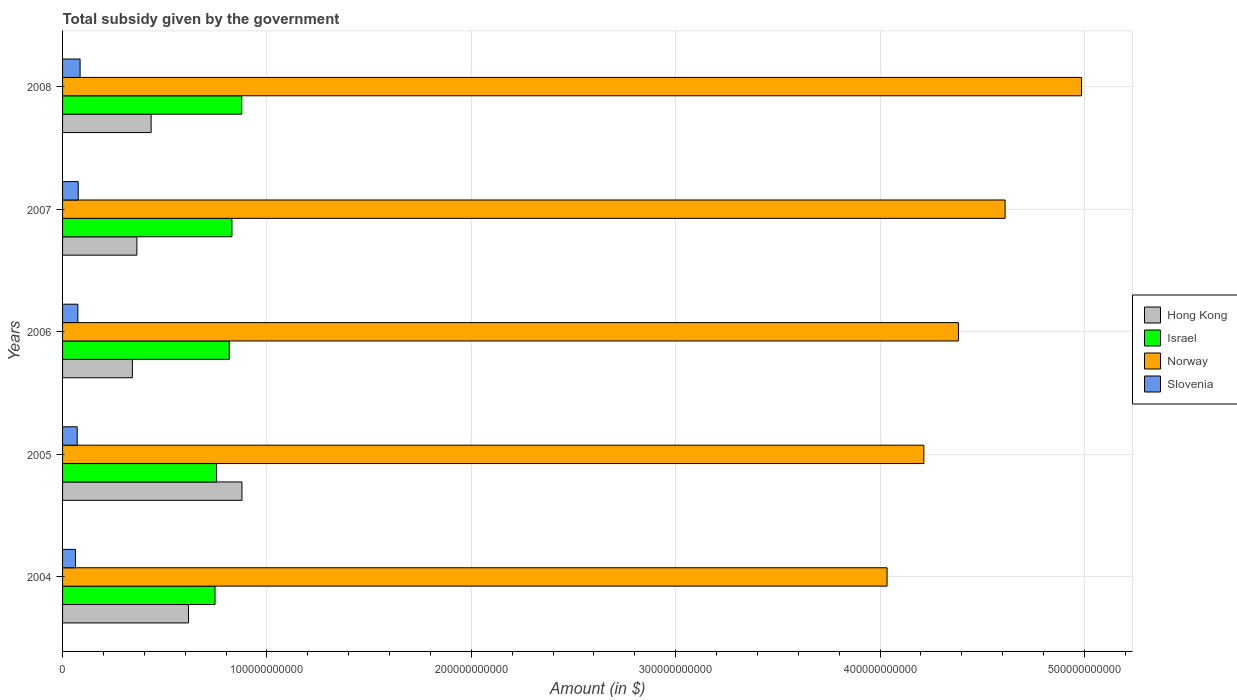How many groups of bars are there?
Your response must be concise. 5. Are the number of bars per tick equal to the number of legend labels?
Offer a very short reply. Yes. How many bars are there on the 3rd tick from the top?
Provide a succinct answer. 4. What is the total revenue collected by the government in Slovenia in 2005?
Your answer should be compact. 7.16e+09. Across all years, what is the maximum total revenue collected by the government in Hong Kong?
Provide a short and direct response. 8.78e+1. Across all years, what is the minimum total revenue collected by the government in Israel?
Make the answer very short. 7.46e+1. In which year was the total revenue collected by the government in Hong Kong minimum?
Keep it short and to the point. 2006. What is the total total revenue collected by the government in Norway in the graph?
Offer a very short reply. 2.22e+12. What is the difference between the total revenue collected by the government in Hong Kong in 2005 and that in 2008?
Your answer should be compact. 4.44e+1. What is the difference between the total revenue collected by the government in Hong Kong in 2004 and the total revenue collected by the government in Norway in 2005?
Give a very brief answer. -3.60e+11. What is the average total revenue collected by the government in Norway per year?
Offer a very short reply. 4.45e+11. In the year 2006, what is the difference between the total revenue collected by the government in Norway and total revenue collected by the government in Hong Kong?
Keep it short and to the point. 4.04e+11. In how many years, is the total revenue collected by the government in Norway greater than 220000000000 $?
Ensure brevity in your answer.  5. What is the ratio of the total revenue collected by the government in Israel in 2004 to that in 2006?
Ensure brevity in your answer.  0.91. Is the total revenue collected by the government in Slovenia in 2006 less than that in 2008?
Provide a succinct answer. Yes. What is the difference between the highest and the second highest total revenue collected by the government in Israel?
Provide a short and direct response. 4.80e+09. What is the difference between the highest and the lowest total revenue collected by the government in Israel?
Make the answer very short. 1.31e+1. Is the sum of the total revenue collected by the government in Norway in 2004 and 2008 greater than the maximum total revenue collected by the government in Hong Kong across all years?
Your answer should be compact. Yes. Is it the case that in every year, the sum of the total revenue collected by the government in Slovenia and total revenue collected by the government in Hong Kong is greater than the sum of total revenue collected by the government in Israel and total revenue collected by the government in Norway?
Give a very brief answer. No. What does the 4th bar from the bottom in 2007 represents?
Your answer should be compact. Slovenia. Are all the bars in the graph horizontal?
Your answer should be very brief. Yes. How many years are there in the graph?
Offer a terse response. 5. What is the difference between two consecutive major ticks on the X-axis?
Give a very brief answer. 1.00e+11. How are the legend labels stacked?
Provide a short and direct response. Vertical. What is the title of the graph?
Ensure brevity in your answer.  Total subsidy given by the government. Does "Bhutan" appear as one of the legend labels in the graph?
Provide a short and direct response. No. What is the label or title of the X-axis?
Give a very brief answer. Amount (in $). What is the Amount (in $) in Hong Kong in 2004?
Offer a terse response. 6.16e+1. What is the Amount (in $) of Israel in 2004?
Provide a succinct answer. 7.46e+1. What is the Amount (in $) of Norway in 2004?
Provide a short and direct response. 4.03e+11. What is the Amount (in $) of Slovenia in 2004?
Give a very brief answer. 6.31e+09. What is the Amount (in $) in Hong Kong in 2005?
Make the answer very short. 8.78e+1. What is the Amount (in $) in Israel in 2005?
Offer a terse response. 7.53e+1. What is the Amount (in $) in Norway in 2005?
Keep it short and to the point. 4.21e+11. What is the Amount (in $) in Slovenia in 2005?
Offer a very short reply. 7.16e+09. What is the Amount (in $) of Hong Kong in 2006?
Provide a succinct answer. 3.42e+1. What is the Amount (in $) in Israel in 2006?
Offer a very short reply. 8.16e+1. What is the Amount (in $) in Norway in 2006?
Keep it short and to the point. 4.38e+11. What is the Amount (in $) of Slovenia in 2006?
Make the answer very short. 7.48e+09. What is the Amount (in $) in Hong Kong in 2007?
Provide a short and direct response. 3.64e+1. What is the Amount (in $) in Israel in 2007?
Give a very brief answer. 8.29e+1. What is the Amount (in $) in Norway in 2007?
Your answer should be compact. 4.61e+11. What is the Amount (in $) of Slovenia in 2007?
Your answer should be very brief. 7.66e+09. What is the Amount (in $) in Hong Kong in 2008?
Keep it short and to the point. 4.33e+1. What is the Amount (in $) in Israel in 2008?
Offer a very short reply. 8.77e+1. What is the Amount (in $) of Norway in 2008?
Make the answer very short. 4.99e+11. What is the Amount (in $) in Slovenia in 2008?
Make the answer very short. 8.58e+09. Across all years, what is the maximum Amount (in $) of Hong Kong?
Provide a short and direct response. 8.78e+1. Across all years, what is the maximum Amount (in $) of Israel?
Keep it short and to the point. 8.77e+1. Across all years, what is the maximum Amount (in $) of Norway?
Your answer should be very brief. 4.99e+11. Across all years, what is the maximum Amount (in $) in Slovenia?
Your answer should be compact. 8.58e+09. Across all years, what is the minimum Amount (in $) of Hong Kong?
Provide a short and direct response. 3.42e+1. Across all years, what is the minimum Amount (in $) in Israel?
Offer a terse response. 7.46e+1. Across all years, what is the minimum Amount (in $) in Norway?
Provide a succinct answer. 4.03e+11. Across all years, what is the minimum Amount (in $) of Slovenia?
Provide a succinct answer. 6.31e+09. What is the total Amount (in $) in Hong Kong in the graph?
Your answer should be compact. 2.63e+11. What is the total Amount (in $) in Israel in the graph?
Offer a very short reply. 4.02e+11. What is the total Amount (in $) of Norway in the graph?
Offer a very short reply. 2.22e+12. What is the total Amount (in $) of Slovenia in the graph?
Offer a terse response. 3.72e+1. What is the difference between the Amount (in $) of Hong Kong in 2004 and that in 2005?
Your answer should be compact. -2.62e+1. What is the difference between the Amount (in $) in Israel in 2004 and that in 2005?
Make the answer very short. -7.47e+08. What is the difference between the Amount (in $) in Norway in 2004 and that in 2005?
Your response must be concise. -1.80e+1. What is the difference between the Amount (in $) in Slovenia in 2004 and that in 2005?
Provide a succinct answer. -8.53e+08. What is the difference between the Amount (in $) in Hong Kong in 2004 and that in 2006?
Your response must be concise. 2.75e+1. What is the difference between the Amount (in $) in Israel in 2004 and that in 2006?
Your answer should be very brief. -6.97e+09. What is the difference between the Amount (in $) in Norway in 2004 and that in 2006?
Your answer should be compact. -3.49e+1. What is the difference between the Amount (in $) of Slovenia in 2004 and that in 2006?
Make the answer very short. -1.18e+09. What is the difference between the Amount (in $) in Hong Kong in 2004 and that in 2007?
Your answer should be very brief. 2.53e+1. What is the difference between the Amount (in $) in Israel in 2004 and that in 2007?
Give a very brief answer. -8.28e+09. What is the difference between the Amount (in $) of Norway in 2004 and that in 2007?
Offer a very short reply. -5.78e+1. What is the difference between the Amount (in $) in Slovenia in 2004 and that in 2007?
Give a very brief answer. -1.35e+09. What is the difference between the Amount (in $) of Hong Kong in 2004 and that in 2008?
Provide a succinct answer. 1.83e+1. What is the difference between the Amount (in $) in Israel in 2004 and that in 2008?
Offer a very short reply. -1.31e+1. What is the difference between the Amount (in $) in Norway in 2004 and that in 2008?
Provide a succinct answer. -9.51e+1. What is the difference between the Amount (in $) of Slovenia in 2004 and that in 2008?
Provide a short and direct response. -2.27e+09. What is the difference between the Amount (in $) in Hong Kong in 2005 and that in 2006?
Provide a succinct answer. 5.36e+1. What is the difference between the Amount (in $) of Israel in 2005 and that in 2006?
Your answer should be compact. -6.22e+09. What is the difference between the Amount (in $) of Norway in 2005 and that in 2006?
Your response must be concise. -1.69e+1. What is the difference between the Amount (in $) of Slovenia in 2005 and that in 2006?
Your answer should be very brief. -3.23e+08. What is the difference between the Amount (in $) in Hong Kong in 2005 and that in 2007?
Offer a very short reply. 5.14e+1. What is the difference between the Amount (in $) of Israel in 2005 and that in 2007?
Offer a very short reply. -7.54e+09. What is the difference between the Amount (in $) of Norway in 2005 and that in 2007?
Offer a very short reply. -3.98e+1. What is the difference between the Amount (in $) of Slovenia in 2005 and that in 2007?
Provide a short and direct response. -4.96e+08. What is the difference between the Amount (in $) of Hong Kong in 2005 and that in 2008?
Provide a succinct answer. 4.44e+1. What is the difference between the Amount (in $) of Israel in 2005 and that in 2008?
Your response must be concise. -1.23e+1. What is the difference between the Amount (in $) in Norway in 2005 and that in 2008?
Provide a short and direct response. -7.71e+1. What is the difference between the Amount (in $) of Slovenia in 2005 and that in 2008?
Make the answer very short. -1.42e+09. What is the difference between the Amount (in $) in Hong Kong in 2006 and that in 2007?
Offer a very short reply. -2.20e+09. What is the difference between the Amount (in $) in Israel in 2006 and that in 2007?
Your response must be concise. -1.32e+09. What is the difference between the Amount (in $) in Norway in 2006 and that in 2007?
Keep it short and to the point. -2.28e+1. What is the difference between the Amount (in $) of Slovenia in 2006 and that in 2007?
Your answer should be very brief. -1.73e+08. What is the difference between the Amount (in $) in Hong Kong in 2006 and that in 2008?
Your answer should be very brief. -9.17e+09. What is the difference between the Amount (in $) in Israel in 2006 and that in 2008?
Your answer should be very brief. -6.12e+09. What is the difference between the Amount (in $) of Norway in 2006 and that in 2008?
Keep it short and to the point. -6.02e+1. What is the difference between the Amount (in $) of Slovenia in 2006 and that in 2008?
Your response must be concise. -1.09e+09. What is the difference between the Amount (in $) in Hong Kong in 2007 and that in 2008?
Provide a short and direct response. -6.98e+09. What is the difference between the Amount (in $) of Israel in 2007 and that in 2008?
Give a very brief answer. -4.80e+09. What is the difference between the Amount (in $) of Norway in 2007 and that in 2008?
Offer a terse response. -3.74e+1. What is the difference between the Amount (in $) in Slovenia in 2007 and that in 2008?
Your response must be concise. -9.21e+08. What is the difference between the Amount (in $) of Hong Kong in 2004 and the Amount (in $) of Israel in 2005?
Offer a very short reply. -1.37e+1. What is the difference between the Amount (in $) of Hong Kong in 2004 and the Amount (in $) of Norway in 2005?
Keep it short and to the point. -3.60e+11. What is the difference between the Amount (in $) in Hong Kong in 2004 and the Amount (in $) in Slovenia in 2005?
Your answer should be very brief. 5.45e+1. What is the difference between the Amount (in $) of Israel in 2004 and the Amount (in $) of Norway in 2005?
Provide a succinct answer. -3.47e+11. What is the difference between the Amount (in $) of Israel in 2004 and the Amount (in $) of Slovenia in 2005?
Provide a short and direct response. 6.74e+1. What is the difference between the Amount (in $) of Norway in 2004 and the Amount (in $) of Slovenia in 2005?
Keep it short and to the point. 3.96e+11. What is the difference between the Amount (in $) in Hong Kong in 2004 and the Amount (in $) in Israel in 2006?
Offer a very short reply. -1.99e+1. What is the difference between the Amount (in $) of Hong Kong in 2004 and the Amount (in $) of Norway in 2006?
Provide a short and direct response. -3.77e+11. What is the difference between the Amount (in $) in Hong Kong in 2004 and the Amount (in $) in Slovenia in 2006?
Your answer should be compact. 5.41e+1. What is the difference between the Amount (in $) of Israel in 2004 and the Amount (in $) of Norway in 2006?
Make the answer very short. -3.64e+11. What is the difference between the Amount (in $) of Israel in 2004 and the Amount (in $) of Slovenia in 2006?
Keep it short and to the point. 6.71e+1. What is the difference between the Amount (in $) of Norway in 2004 and the Amount (in $) of Slovenia in 2006?
Your answer should be compact. 3.96e+11. What is the difference between the Amount (in $) of Hong Kong in 2004 and the Amount (in $) of Israel in 2007?
Ensure brevity in your answer.  -2.13e+1. What is the difference between the Amount (in $) in Hong Kong in 2004 and the Amount (in $) in Norway in 2007?
Give a very brief answer. -4.00e+11. What is the difference between the Amount (in $) in Hong Kong in 2004 and the Amount (in $) in Slovenia in 2007?
Make the answer very short. 5.40e+1. What is the difference between the Amount (in $) of Israel in 2004 and the Amount (in $) of Norway in 2007?
Your answer should be very brief. -3.87e+11. What is the difference between the Amount (in $) of Israel in 2004 and the Amount (in $) of Slovenia in 2007?
Offer a very short reply. 6.69e+1. What is the difference between the Amount (in $) of Norway in 2004 and the Amount (in $) of Slovenia in 2007?
Your answer should be very brief. 3.96e+11. What is the difference between the Amount (in $) in Hong Kong in 2004 and the Amount (in $) in Israel in 2008?
Provide a succinct answer. -2.61e+1. What is the difference between the Amount (in $) in Hong Kong in 2004 and the Amount (in $) in Norway in 2008?
Make the answer very short. -4.37e+11. What is the difference between the Amount (in $) of Hong Kong in 2004 and the Amount (in $) of Slovenia in 2008?
Offer a very short reply. 5.30e+1. What is the difference between the Amount (in $) of Israel in 2004 and the Amount (in $) of Norway in 2008?
Your answer should be compact. -4.24e+11. What is the difference between the Amount (in $) of Israel in 2004 and the Amount (in $) of Slovenia in 2008?
Your response must be concise. 6.60e+1. What is the difference between the Amount (in $) in Norway in 2004 and the Amount (in $) in Slovenia in 2008?
Your answer should be very brief. 3.95e+11. What is the difference between the Amount (in $) in Hong Kong in 2005 and the Amount (in $) in Israel in 2006?
Keep it short and to the point. 6.22e+09. What is the difference between the Amount (in $) of Hong Kong in 2005 and the Amount (in $) of Norway in 2006?
Offer a terse response. -3.51e+11. What is the difference between the Amount (in $) in Hong Kong in 2005 and the Amount (in $) in Slovenia in 2006?
Offer a very short reply. 8.03e+1. What is the difference between the Amount (in $) in Israel in 2005 and the Amount (in $) in Norway in 2006?
Keep it short and to the point. -3.63e+11. What is the difference between the Amount (in $) of Israel in 2005 and the Amount (in $) of Slovenia in 2006?
Offer a terse response. 6.79e+1. What is the difference between the Amount (in $) in Norway in 2005 and the Amount (in $) in Slovenia in 2006?
Ensure brevity in your answer.  4.14e+11. What is the difference between the Amount (in $) in Hong Kong in 2005 and the Amount (in $) in Israel in 2007?
Your answer should be very brief. 4.90e+09. What is the difference between the Amount (in $) in Hong Kong in 2005 and the Amount (in $) in Norway in 2007?
Make the answer very short. -3.73e+11. What is the difference between the Amount (in $) of Hong Kong in 2005 and the Amount (in $) of Slovenia in 2007?
Your answer should be compact. 8.01e+1. What is the difference between the Amount (in $) in Israel in 2005 and the Amount (in $) in Norway in 2007?
Keep it short and to the point. -3.86e+11. What is the difference between the Amount (in $) in Israel in 2005 and the Amount (in $) in Slovenia in 2007?
Your answer should be very brief. 6.77e+1. What is the difference between the Amount (in $) of Norway in 2005 and the Amount (in $) of Slovenia in 2007?
Your answer should be very brief. 4.14e+11. What is the difference between the Amount (in $) in Hong Kong in 2005 and the Amount (in $) in Israel in 2008?
Keep it short and to the point. 9.97e+07. What is the difference between the Amount (in $) in Hong Kong in 2005 and the Amount (in $) in Norway in 2008?
Provide a succinct answer. -4.11e+11. What is the difference between the Amount (in $) of Hong Kong in 2005 and the Amount (in $) of Slovenia in 2008?
Your answer should be compact. 7.92e+1. What is the difference between the Amount (in $) of Israel in 2005 and the Amount (in $) of Norway in 2008?
Your answer should be compact. -4.23e+11. What is the difference between the Amount (in $) in Israel in 2005 and the Amount (in $) in Slovenia in 2008?
Give a very brief answer. 6.68e+1. What is the difference between the Amount (in $) of Norway in 2005 and the Amount (in $) of Slovenia in 2008?
Provide a succinct answer. 4.13e+11. What is the difference between the Amount (in $) of Hong Kong in 2006 and the Amount (in $) of Israel in 2007?
Provide a succinct answer. -4.87e+1. What is the difference between the Amount (in $) in Hong Kong in 2006 and the Amount (in $) in Norway in 2007?
Your answer should be very brief. -4.27e+11. What is the difference between the Amount (in $) of Hong Kong in 2006 and the Amount (in $) of Slovenia in 2007?
Provide a succinct answer. 2.65e+1. What is the difference between the Amount (in $) in Israel in 2006 and the Amount (in $) in Norway in 2007?
Provide a short and direct response. -3.80e+11. What is the difference between the Amount (in $) of Israel in 2006 and the Amount (in $) of Slovenia in 2007?
Ensure brevity in your answer.  7.39e+1. What is the difference between the Amount (in $) in Norway in 2006 and the Amount (in $) in Slovenia in 2007?
Your response must be concise. 4.31e+11. What is the difference between the Amount (in $) in Hong Kong in 2006 and the Amount (in $) in Israel in 2008?
Provide a short and direct response. -5.35e+1. What is the difference between the Amount (in $) in Hong Kong in 2006 and the Amount (in $) in Norway in 2008?
Offer a very short reply. -4.64e+11. What is the difference between the Amount (in $) of Hong Kong in 2006 and the Amount (in $) of Slovenia in 2008?
Give a very brief answer. 2.56e+1. What is the difference between the Amount (in $) of Israel in 2006 and the Amount (in $) of Norway in 2008?
Keep it short and to the point. -4.17e+11. What is the difference between the Amount (in $) of Israel in 2006 and the Amount (in $) of Slovenia in 2008?
Your response must be concise. 7.30e+1. What is the difference between the Amount (in $) in Norway in 2006 and the Amount (in $) in Slovenia in 2008?
Offer a terse response. 4.30e+11. What is the difference between the Amount (in $) of Hong Kong in 2007 and the Amount (in $) of Israel in 2008?
Make the answer very short. -5.13e+1. What is the difference between the Amount (in $) in Hong Kong in 2007 and the Amount (in $) in Norway in 2008?
Keep it short and to the point. -4.62e+11. What is the difference between the Amount (in $) in Hong Kong in 2007 and the Amount (in $) in Slovenia in 2008?
Keep it short and to the point. 2.78e+1. What is the difference between the Amount (in $) of Israel in 2007 and the Amount (in $) of Norway in 2008?
Your response must be concise. -4.16e+11. What is the difference between the Amount (in $) in Israel in 2007 and the Amount (in $) in Slovenia in 2008?
Provide a short and direct response. 7.43e+1. What is the difference between the Amount (in $) of Norway in 2007 and the Amount (in $) of Slovenia in 2008?
Offer a very short reply. 4.53e+11. What is the average Amount (in $) of Hong Kong per year?
Ensure brevity in your answer.  5.26e+1. What is the average Amount (in $) in Israel per year?
Your answer should be very brief. 8.04e+1. What is the average Amount (in $) in Norway per year?
Make the answer very short. 4.45e+11. What is the average Amount (in $) of Slovenia per year?
Offer a very short reply. 7.44e+09. In the year 2004, what is the difference between the Amount (in $) in Hong Kong and Amount (in $) in Israel?
Your answer should be very brief. -1.30e+1. In the year 2004, what is the difference between the Amount (in $) of Hong Kong and Amount (in $) of Norway?
Provide a short and direct response. -3.42e+11. In the year 2004, what is the difference between the Amount (in $) of Hong Kong and Amount (in $) of Slovenia?
Keep it short and to the point. 5.53e+1. In the year 2004, what is the difference between the Amount (in $) in Israel and Amount (in $) in Norway?
Your response must be concise. -3.29e+11. In the year 2004, what is the difference between the Amount (in $) of Israel and Amount (in $) of Slovenia?
Make the answer very short. 6.83e+1. In the year 2004, what is the difference between the Amount (in $) in Norway and Amount (in $) in Slovenia?
Provide a short and direct response. 3.97e+11. In the year 2005, what is the difference between the Amount (in $) of Hong Kong and Amount (in $) of Israel?
Ensure brevity in your answer.  1.24e+1. In the year 2005, what is the difference between the Amount (in $) of Hong Kong and Amount (in $) of Norway?
Offer a very short reply. -3.34e+11. In the year 2005, what is the difference between the Amount (in $) in Hong Kong and Amount (in $) in Slovenia?
Provide a short and direct response. 8.06e+1. In the year 2005, what is the difference between the Amount (in $) in Israel and Amount (in $) in Norway?
Ensure brevity in your answer.  -3.46e+11. In the year 2005, what is the difference between the Amount (in $) in Israel and Amount (in $) in Slovenia?
Ensure brevity in your answer.  6.82e+1. In the year 2005, what is the difference between the Amount (in $) of Norway and Amount (in $) of Slovenia?
Your answer should be very brief. 4.14e+11. In the year 2006, what is the difference between the Amount (in $) of Hong Kong and Amount (in $) of Israel?
Keep it short and to the point. -4.74e+1. In the year 2006, what is the difference between the Amount (in $) of Hong Kong and Amount (in $) of Norway?
Offer a very short reply. -4.04e+11. In the year 2006, what is the difference between the Amount (in $) of Hong Kong and Amount (in $) of Slovenia?
Give a very brief answer. 2.67e+1. In the year 2006, what is the difference between the Amount (in $) in Israel and Amount (in $) in Norway?
Provide a succinct answer. -3.57e+11. In the year 2006, what is the difference between the Amount (in $) in Israel and Amount (in $) in Slovenia?
Your answer should be very brief. 7.41e+1. In the year 2006, what is the difference between the Amount (in $) in Norway and Amount (in $) in Slovenia?
Offer a very short reply. 4.31e+11. In the year 2007, what is the difference between the Amount (in $) of Hong Kong and Amount (in $) of Israel?
Your response must be concise. -4.65e+1. In the year 2007, what is the difference between the Amount (in $) of Hong Kong and Amount (in $) of Norway?
Provide a short and direct response. -4.25e+11. In the year 2007, what is the difference between the Amount (in $) in Hong Kong and Amount (in $) in Slovenia?
Your answer should be very brief. 2.87e+1. In the year 2007, what is the difference between the Amount (in $) in Israel and Amount (in $) in Norway?
Your answer should be compact. -3.78e+11. In the year 2007, what is the difference between the Amount (in $) in Israel and Amount (in $) in Slovenia?
Provide a short and direct response. 7.52e+1. In the year 2007, what is the difference between the Amount (in $) in Norway and Amount (in $) in Slovenia?
Keep it short and to the point. 4.54e+11. In the year 2008, what is the difference between the Amount (in $) in Hong Kong and Amount (in $) in Israel?
Your response must be concise. -4.43e+1. In the year 2008, what is the difference between the Amount (in $) in Hong Kong and Amount (in $) in Norway?
Your answer should be very brief. -4.55e+11. In the year 2008, what is the difference between the Amount (in $) in Hong Kong and Amount (in $) in Slovenia?
Ensure brevity in your answer.  3.48e+1. In the year 2008, what is the difference between the Amount (in $) in Israel and Amount (in $) in Norway?
Your response must be concise. -4.11e+11. In the year 2008, what is the difference between the Amount (in $) in Israel and Amount (in $) in Slovenia?
Give a very brief answer. 7.91e+1. In the year 2008, what is the difference between the Amount (in $) in Norway and Amount (in $) in Slovenia?
Keep it short and to the point. 4.90e+11. What is the ratio of the Amount (in $) of Hong Kong in 2004 to that in 2005?
Offer a very short reply. 0.7. What is the ratio of the Amount (in $) of Norway in 2004 to that in 2005?
Your answer should be very brief. 0.96. What is the ratio of the Amount (in $) in Slovenia in 2004 to that in 2005?
Your answer should be compact. 0.88. What is the ratio of the Amount (in $) in Hong Kong in 2004 to that in 2006?
Your answer should be compact. 1.8. What is the ratio of the Amount (in $) of Israel in 2004 to that in 2006?
Your response must be concise. 0.91. What is the ratio of the Amount (in $) in Norway in 2004 to that in 2006?
Offer a very short reply. 0.92. What is the ratio of the Amount (in $) in Slovenia in 2004 to that in 2006?
Your answer should be compact. 0.84. What is the ratio of the Amount (in $) of Hong Kong in 2004 to that in 2007?
Offer a very short reply. 1.7. What is the ratio of the Amount (in $) of Israel in 2004 to that in 2007?
Make the answer very short. 0.9. What is the ratio of the Amount (in $) of Norway in 2004 to that in 2007?
Your answer should be compact. 0.87. What is the ratio of the Amount (in $) in Slovenia in 2004 to that in 2007?
Your answer should be compact. 0.82. What is the ratio of the Amount (in $) in Hong Kong in 2004 to that in 2008?
Offer a very short reply. 1.42. What is the ratio of the Amount (in $) of Israel in 2004 to that in 2008?
Provide a short and direct response. 0.85. What is the ratio of the Amount (in $) of Norway in 2004 to that in 2008?
Offer a terse response. 0.81. What is the ratio of the Amount (in $) in Slovenia in 2004 to that in 2008?
Provide a short and direct response. 0.74. What is the ratio of the Amount (in $) in Hong Kong in 2005 to that in 2006?
Your answer should be very brief. 2.57. What is the ratio of the Amount (in $) in Israel in 2005 to that in 2006?
Offer a very short reply. 0.92. What is the ratio of the Amount (in $) in Norway in 2005 to that in 2006?
Provide a short and direct response. 0.96. What is the ratio of the Amount (in $) in Slovenia in 2005 to that in 2006?
Make the answer very short. 0.96. What is the ratio of the Amount (in $) in Hong Kong in 2005 to that in 2007?
Give a very brief answer. 2.41. What is the ratio of the Amount (in $) of Israel in 2005 to that in 2007?
Provide a short and direct response. 0.91. What is the ratio of the Amount (in $) in Norway in 2005 to that in 2007?
Make the answer very short. 0.91. What is the ratio of the Amount (in $) in Slovenia in 2005 to that in 2007?
Your answer should be very brief. 0.94. What is the ratio of the Amount (in $) in Hong Kong in 2005 to that in 2008?
Your response must be concise. 2.03. What is the ratio of the Amount (in $) in Israel in 2005 to that in 2008?
Your answer should be compact. 0.86. What is the ratio of the Amount (in $) in Norway in 2005 to that in 2008?
Keep it short and to the point. 0.85. What is the ratio of the Amount (in $) in Slovenia in 2005 to that in 2008?
Your answer should be compact. 0.83. What is the ratio of the Amount (in $) in Hong Kong in 2006 to that in 2007?
Make the answer very short. 0.94. What is the ratio of the Amount (in $) of Israel in 2006 to that in 2007?
Make the answer very short. 0.98. What is the ratio of the Amount (in $) in Norway in 2006 to that in 2007?
Offer a terse response. 0.95. What is the ratio of the Amount (in $) of Slovenia in 2006 to that in 2007?
Ensure brevity in your answer.  0.98. What is the ratio of the Amount (in $) in Hong Kong in 2006 to that in 2008?
Give a very brief answer. 0.79. What is the ratio of the Amount (in $) in Israel in 2006 to that in 2008?
Offer a very short reply. 0.93. What is the ratio of the Amount (in $) in Norway in 2006 to that in 2008?
Ensure brevity in your answer.  0.88. What is the ratio of the Amount (in $) in Slovenia in 2006 to that in 2008?
Give a very brief answer. 0.87. What is the ratio of the Amount (in $) of Hong Kong in 2007 to that in 2008?
Your response must be concise. 0.84. What is the ratio of the Amount (in $) in Israel in 2007 to that in 2008?
Provide a succinct answer. 0.95. What is the ratio of the Amount (in $) in Norway in 2007 to that in 2008?
Give a very brief answer. 0.93. What is the ratio of the Amount (in $) of Slovenia in 2007 to that in 2008?
Give a very brief answer. 0.89. What is the difference between the highest and the second highest Amount (in $) in Hong Kong?
Give a very brief answer. 2.62e+1. What is the difference between the highest and the second highest Amount (in $) in Israel?
Provide a succinct answer. 4.80e+09. What is the difference between the highest and the second highest Amount (in $) in Norway?
Provide a short and direct response. 3.74e+1. What is the difference between the highest and the second highest Amount (in $) in Slovenia?
Make the answer very short. 9.21e+08. What is the difference between the highest and the lowest Amount (in $) in Hong Kong?
Your answer should be compact. 5.36e+1. What is the difference between the highest and the lowest Amount (in $) of Israel?
Offer a terse response. 1.31e+1. What is the difference between the highest and the lowest Amount (in $) in Norway?
Ensure brevity in your answer.  9.51e+1. What is the difference between the highest and the lowest Amount (in $) of Slovenia?
Provide a succinct answer. 2.27e+09. 